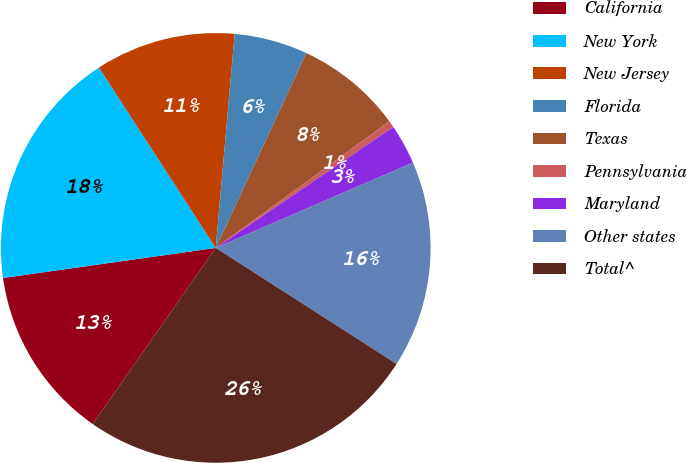Convert chart. <chart><loc_0><loc_0><loc_500><loc_500><pie_chart><fcel>California<fcel>New York<fcel>New Jersey<fcel>Florida<fcel>Texas<fcel>Pennsylvania<fcel>Maryland<fcel>Other states<fcel>Total^<nl><fcel>13.06%<fcel>18.09%<fcel>10.55%<fcel>5.53%<fcel>8.04%<fcel>0.51%<fcel>3.02%<fcel>15.58%<fcel>25.62%<nl></chart> 